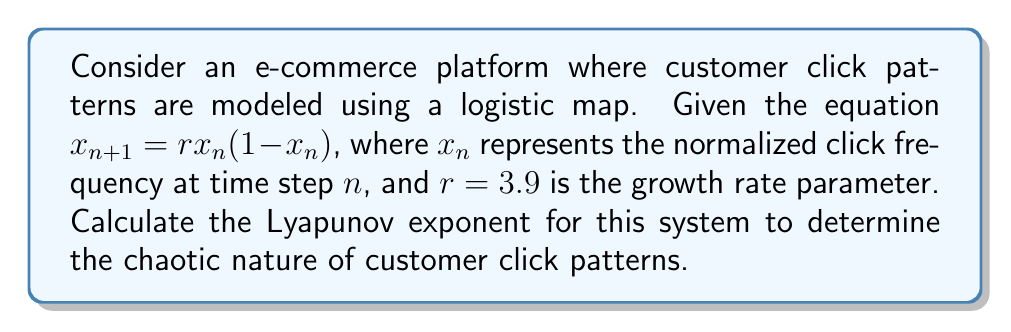Can you solve this math problem? To calculate the Lyapunov exponent for this logistic map:

1. The Lyapunov exponent λ is given by:
   $$\lambda = \lim_{N \to \infty} \frac{1}{N} \sum_{n=0}^{N-1} \ln \left|\frac{df}{dx}(x_n)\right|$$

2. For the logistic map $f(x) = rx(1-x)$, the derivative is:
   $$\frac{df}{dx} = r(1-2x)$$

3. Substitute $r=3.9$ and iterate the map for a large number of steps (e.g., N=10000):
   $$x_{n+1} = 3.9x_n(1-x_n)$$

4. Start with an initial condition (e.g., $x_0 = 0.5$) and compute the sum:
   $$S = \sum_{n=0}^{N-1} \ln |3.9(1-2x_n)|$$

5. Calculate λ:
   $$\lambda = \frac{S}{N}$$

6. Using a computational tool to perform these iterations, we find:
   $$\lambda \approx 0.5756$$

This positive Lyapunov exponent indicates chaotic behavior in customer click patterns.
Answer: $\lambda \approx 0.5756$ 